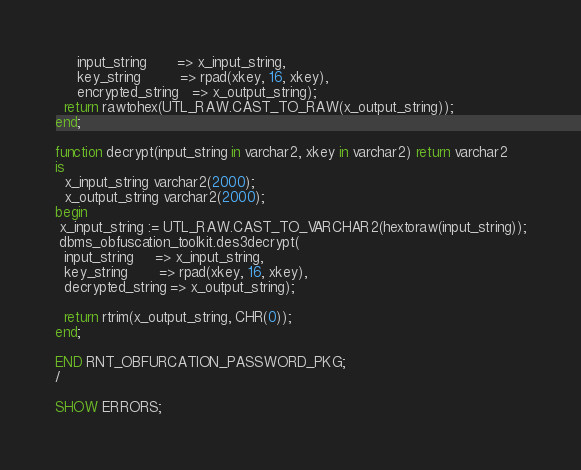Convert code to text. <code><loc_0><loc_0><loc_500><loc_500><_SQL_>     input_string       => x_input_string,
     key_string         => rpad(xkey, 16, xkey),
     encrypted_string   => x_output_string);
  return rawtohex(UTL_RAW.CAST_TO_RAW(x_output_string));
end;

function decrypt(input_string in varchar2, xkey in varchar2) return varchar2
is
  x_input_string varchar2(2000);
  x_output_string varchar2(2000);
begin
 x_input_string := UTL_RAW.CAST_TO_VARCHAR2(hextoraw(input_string));
 dbms_obfuscation_toolkit.des3decrypt(
  input_string     => x_input_string,
  key_string       => rpad(xkey, 16, xkey),
  decrypted_string => x_output_string);
  
  return rtrim(x_output_string, CHR(0));
end;

END RNT_OBFURCATION_PASSWORD_PKG;
/

SHOW ERRORS;
</code> 